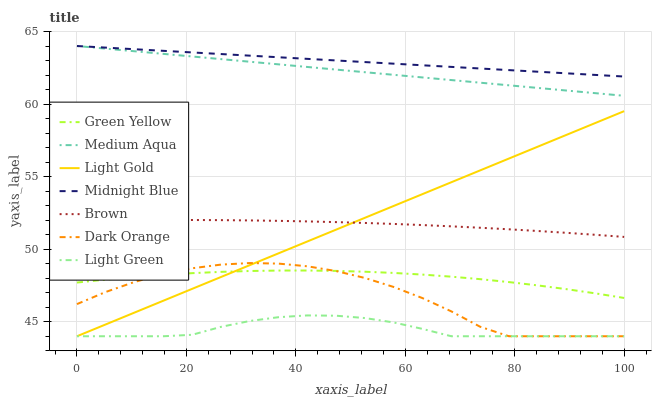Does Brown have the minimum area under the curve?
Answer yes or no. No. Does Brown have the maximum area under the curve?
Answer yes or no. No. Is Brown the smoothest?
Answer yes or no. No. Is Brown the roughest?
Answer yes or no. No. Does Brown have the lowest value?
Answer yes or no. No. Does Brown have the highest value?
Answer yes or no. No. Is Dark Orange less than Brown?
Answer yes or no. Yes. Is Brown greater than Green Yellow?
Answer yes or no. Yes. Does Dark Orange intersect Brown?
Answer yes or no. No. 